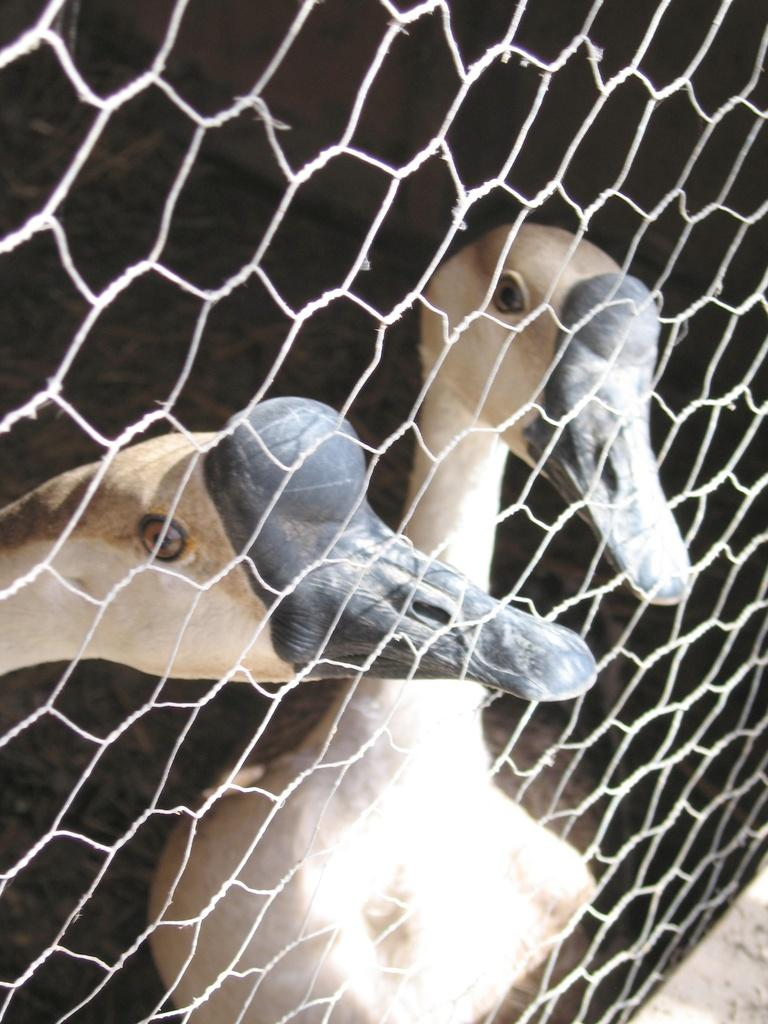How many ducks are present in the image? There are two ducks in the image. What is separating the ducks from the viewer in the image? The ducks are behind a white color net. What type of songs can be heard being sung by the ducks in the image? There are no songs being sung by the ducks in the image, as ducks do not have the ability to sing. 